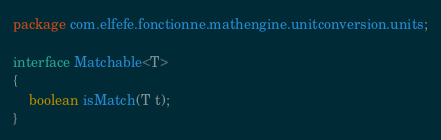<code> <loc_0><loc_0><loc_500><loc_500><_Java_>package com.elfefe.fonctionne.mathengine.unitconversion.units;

interface Matchable<T>
{
	boolean isMatch(T t);
}
</code> 